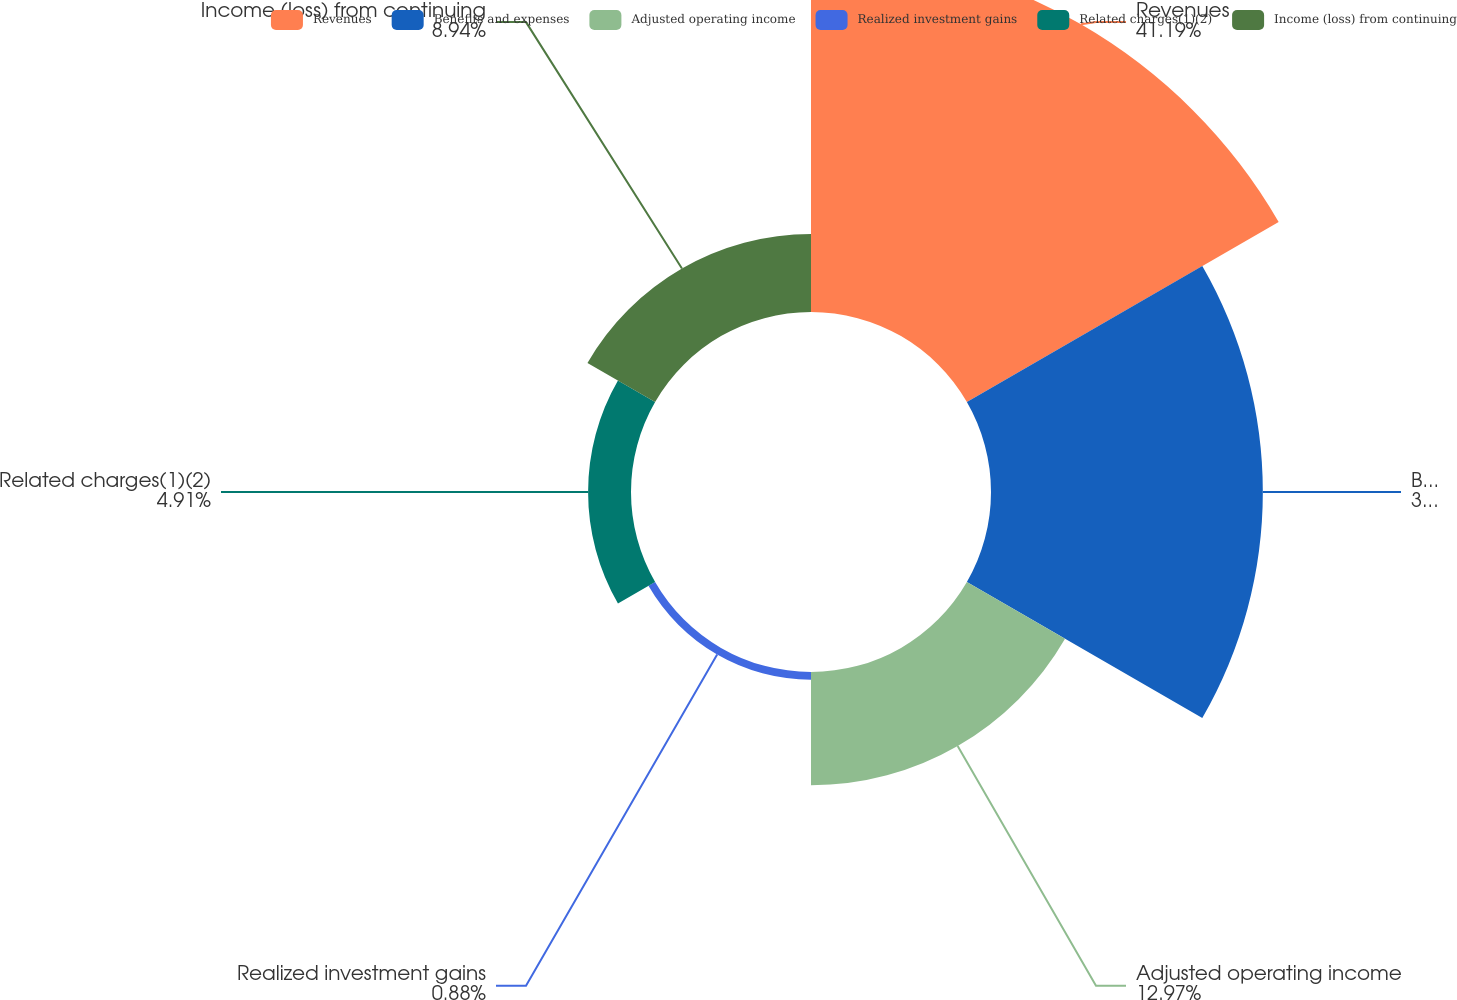<chart> <loc_0><loc_0><loc_500><loc_500><pie_chart><fcel>Revenues<fcel>Benefits and expenses<fcel>Adjusted operating income<fcel>Realized investment gains<fcel>Related charges(1)(2)<fcel>Income (loss) from continuing<nl><fcel>41.2%<fcel>31.11%<fcel>12.97%<fcel>0.88%<fcel>4.91%<fcel>8.94%<nl></chart> 